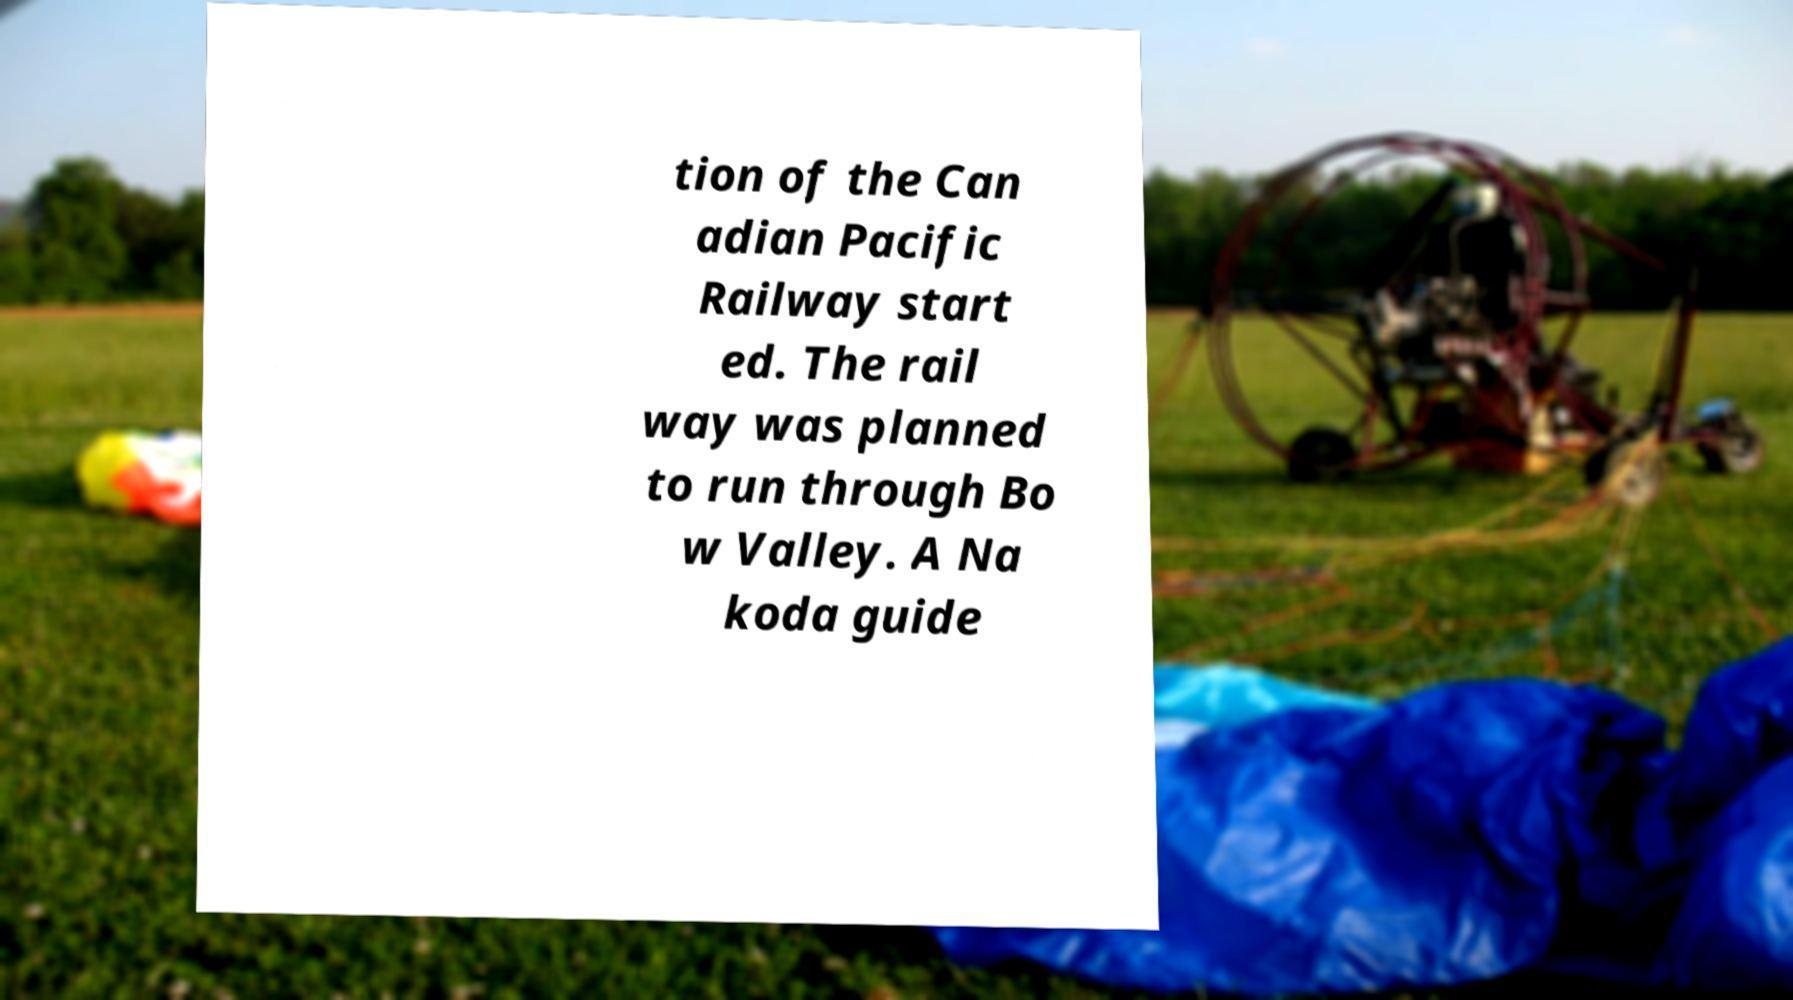Please identify and transcribe the text found in this image. tion of the Can adian Pacific Railway start ed. The rail way was planned to run through Bo w Valley. A Na koda guide 